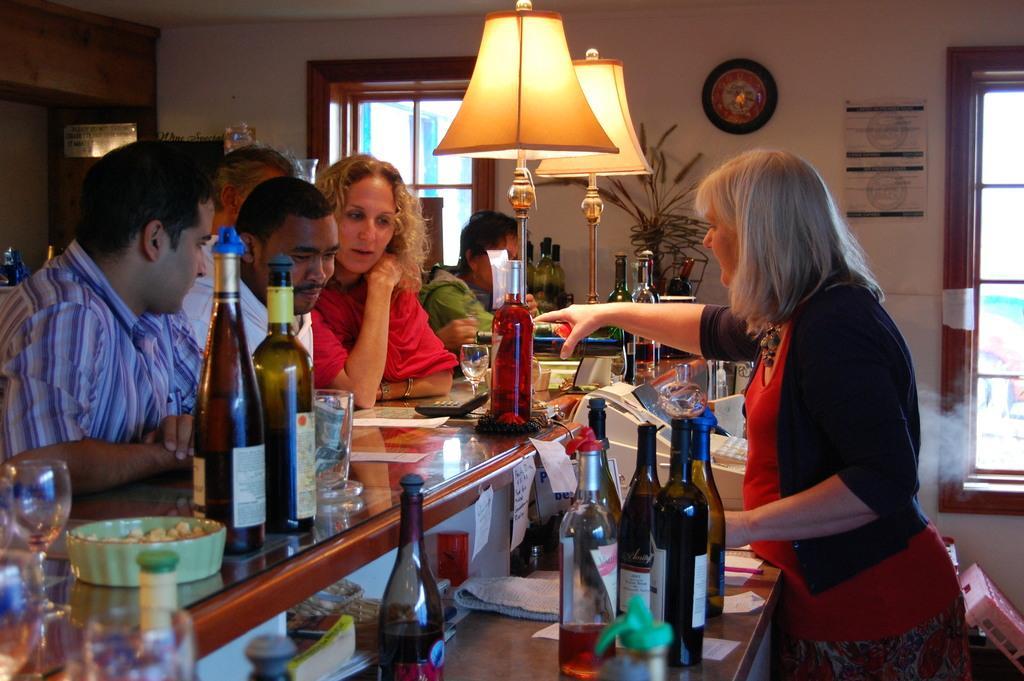In one or two sentences, can you explain what this image depicts? In this image I can see few people and number of bottles on this desk. I can also see lamps and a clock on this wall. Here I can see few glasses and a plate. 